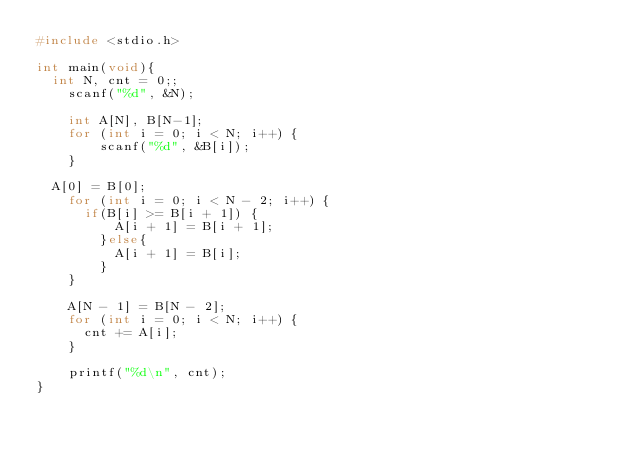Convert code to text. <code><loc_0><loc_0><loc_500><loc_500><_C_>#include <stdio.h>

int main(void){
	int N, cnt = 0;;
  	scanf("%d", &N);

  	int A[N], B[N-1];
  	for (int i = 0; i < N; i++) {
      	scanf("%d", &B[i]);
    }

	A[0] = B[0];
  	for (int i = 0; i < N - 2; i++) {
    	if(B[i] >= B[i + 1]) {
        	A[i + 1] = B[i + 1];
        }else{
        	A[i + 1] = B[i];
        }
    }

  	A[N - 1] = B[N - 2];
    for (int i = 0; i < N; i++) {
    	cnt += A[i];
    }

  	printf("%d\n", cnt);
}
</code> 